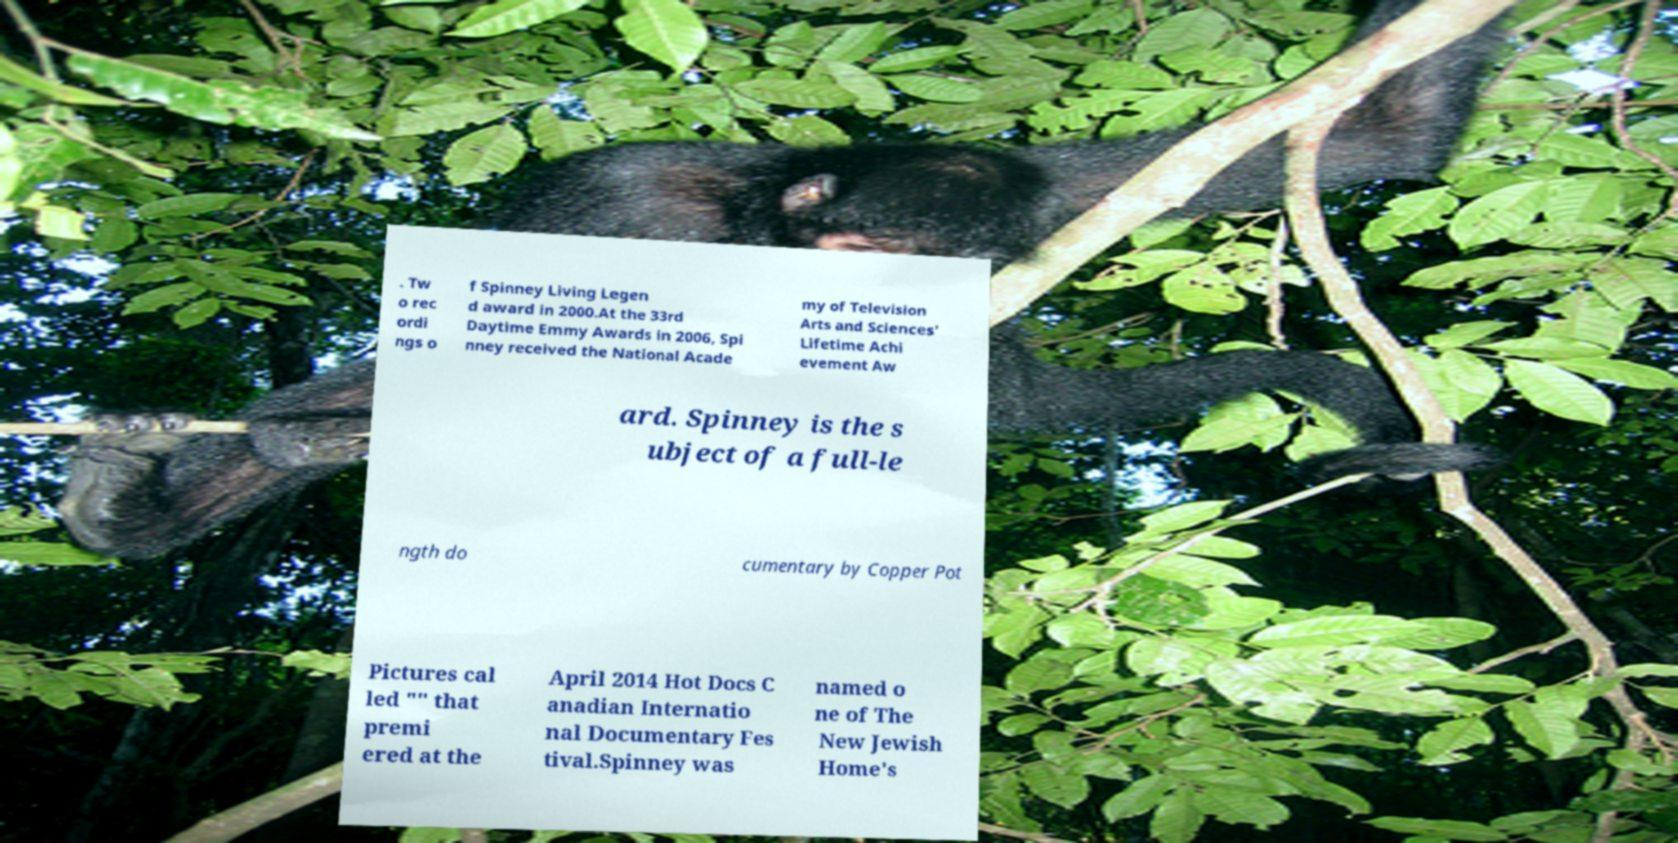Can you accurately transcribe the text from the provided image for me? . Tw o rec ordi ngs o f Spinney Living Legen d award in 2000.At the 33rd Daytime Emmy Awards in 2006, Spi nney received the National Acade my of Television Arts and Sciences' Lifetime Achi evement Aw ard. Spinney is the s ubject of a full-le ngth do cumentary by Copper Pot Pictures cal led "" that premi ered at the April 2014 Hot Docs C anadian Internatio nal Documentary Fes tival.Spinney was named o ne of The New Jewish Home's 